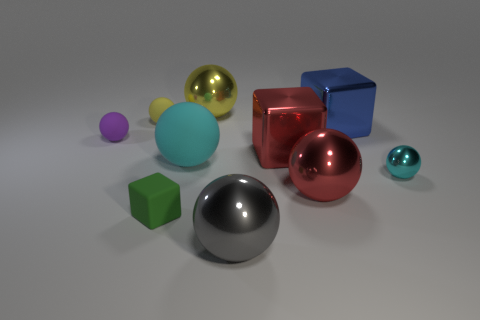The sphere that is the same color as the small shiny object is what size?
Ensure brevity in your answer.  Large. Does the small metal thing have the same color as the large matte sphere?
Give a very brief answer. Yes. How many other objects are there of the same color as the big matte ball?
Make the answer very short. 1. The thing that is on the left side of the yellow matte object has what shape?
Ensure brevity in your answer.  Sphere. What is the shape of the rubber object that is behind the large cyan ball and in front of the tiny yellow rubber ball?
Ensure brevity in your answer.  Sphere. What number of red things are either balls or matte cubes?
Keep it short and to the point. 1. Does the large metallic ball that is behind the small cyan sphere have the same color as the large rubber thing?
Offer a terse response. No. How big is the red thing that is right of the red thing behind the cyan rubber object?
Ensure brevity in your answer.  Large. What is the material of the cube that is the same size as the cyan metal sphere?
Your response must be concise. Rubber. What number of other objects are there of the same size as the blue thing?
Make the answer very short. 5. 